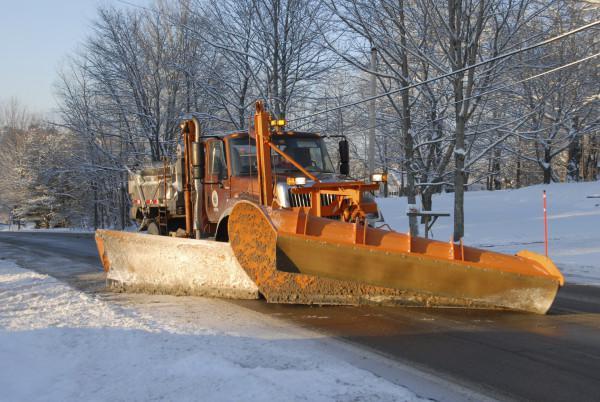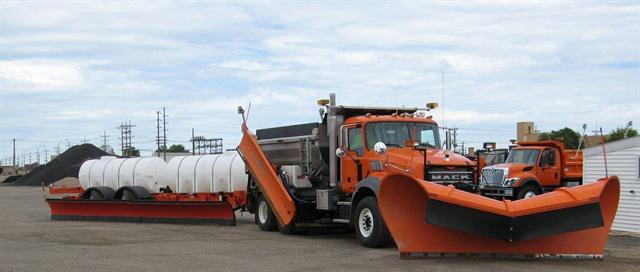The first image is the image on the left, the second image is the image on the right. For the images displayed, is the sentence "The left and right image contains the same number of snow dump trunks." factually correct? Answer yes or no. No. The first image is the image on the left, the second image is the image on the right. For the images displayed, is the sentence "Both plows are attached to large trucks and have visible snow on them." factually correct? Answer yes or no. No. 